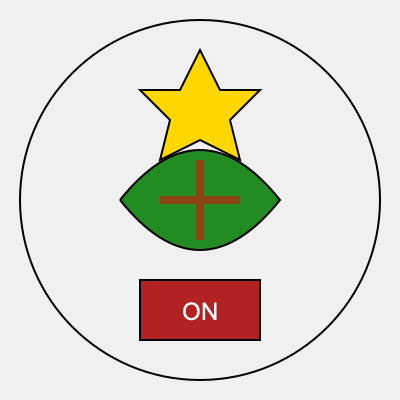Which Ontario provincial symbol is not represented in the stylized icon set? To answer this question, we need to analyze the stylized icons and identify the Ontario provincial symbols they represent:

1. The green curved shape in the center represents a trillium, which is Ontario's official flower.
2. The brown cross-like shape overlapping the trillium represents the white pine, Ontario's official tree.
3. The yellow star-like shape at the top represents the amethyst, Ontario's official mineral.
4. The red rectangle at the bottom with "ON" written on it represents Ontario's license plate.

Now, let's consider the official symbols of Ontario:
- Official flower: Trillium (represented)
- Official tree: Eastern White Pine (represented)
- Official bird: Common Loon (not represented)
- Official mineral: Amethyst (represented)
- Official gemstone: Amethyst (represented by the same icon as the mineral)

By comparing the list of official symbols with the icons in the image, we can see that the Common Loon, Ontario's official bird, is not represented in the stylized icon set.
Answer: Common Loon 